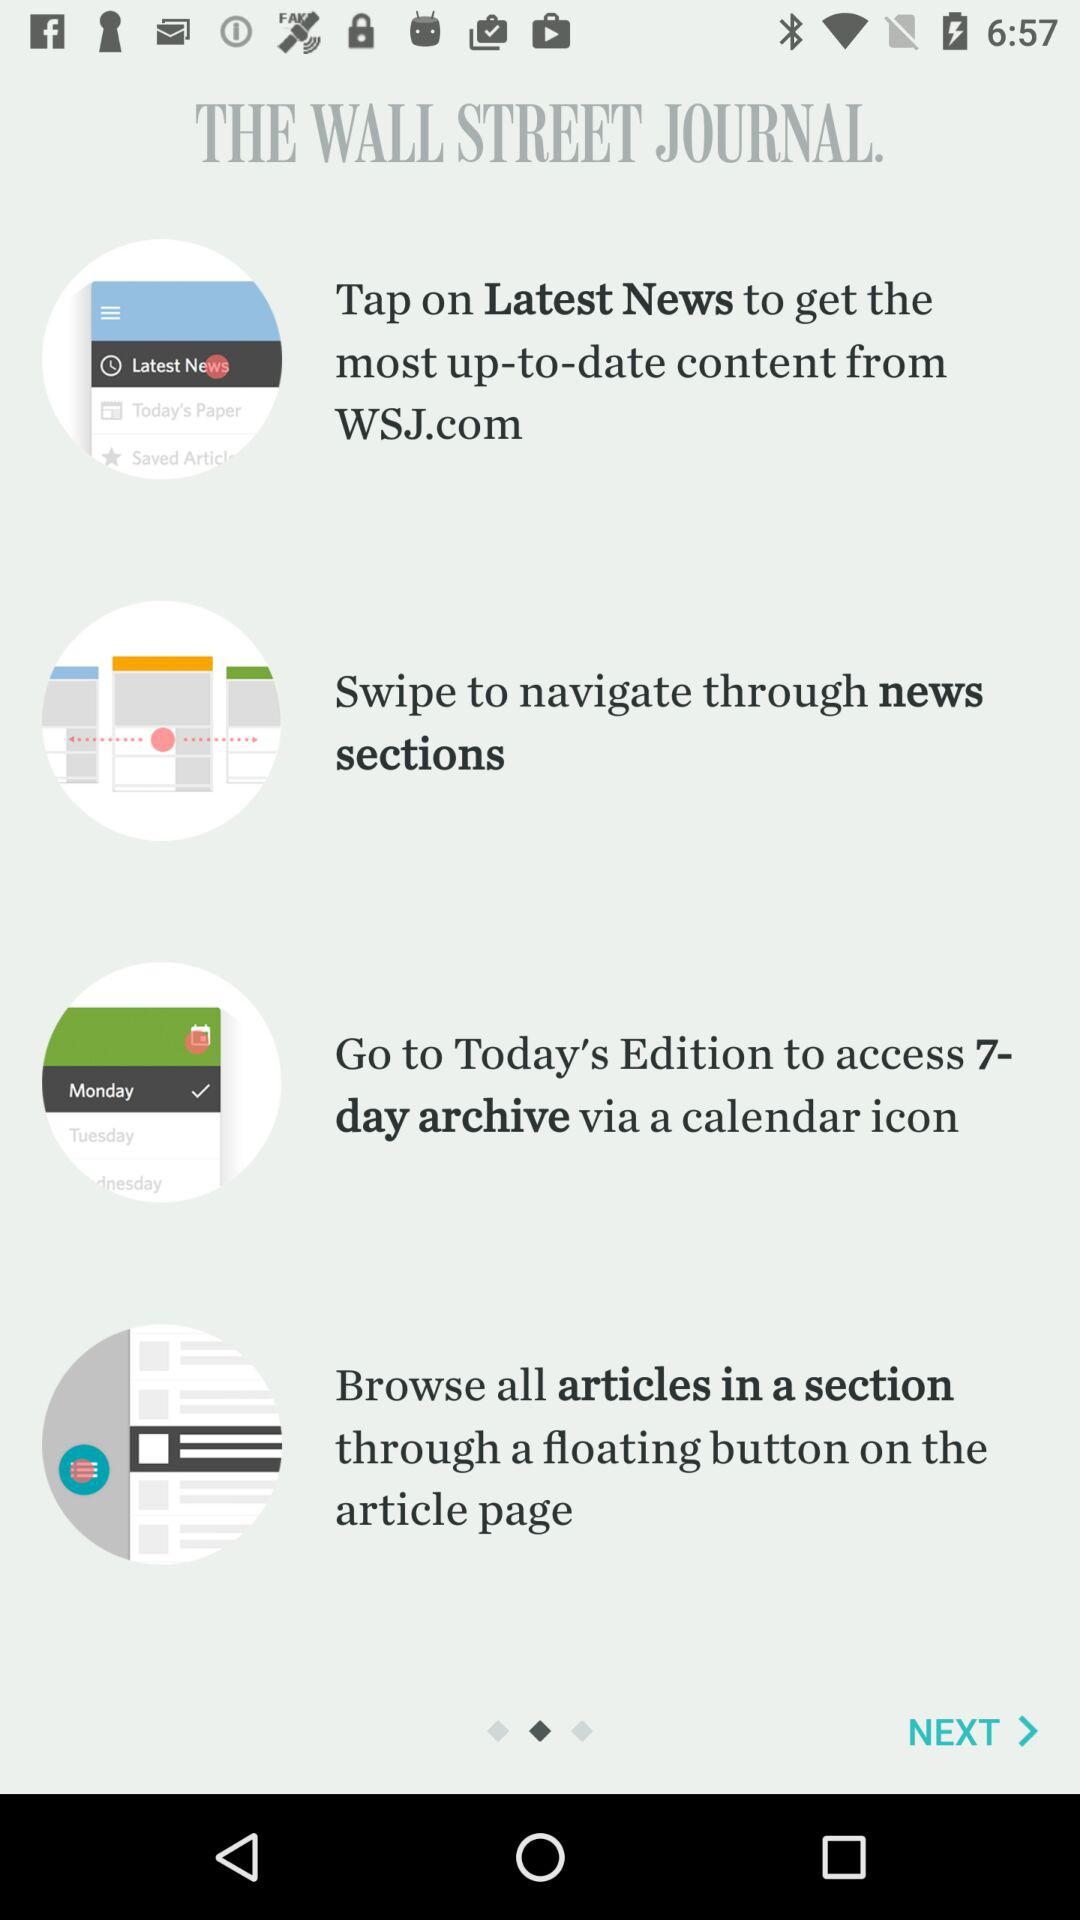How many items are displayed in the pager indicator?
Answer the question using a single word or phrase. 4 